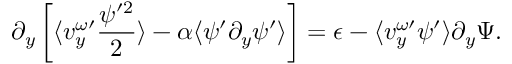<formula> <loc_0><loc_0><loc_500><loc_500>\partial _ { y } \left [ \langle v _ { y } ^ { \omega \prime } \frac { \psi ^ { \prime 2 } } { 2 } \rangle - \alpha \langle \psi ^ { \prime } \partial _ { y } \psi ^ { \prime } \rangle \right ] = \epsilon - \langle v _ { y } ^ { \omega \prime } \psi ^ { \prime } \rangle \partial _ { y } \Psi .</formula> 